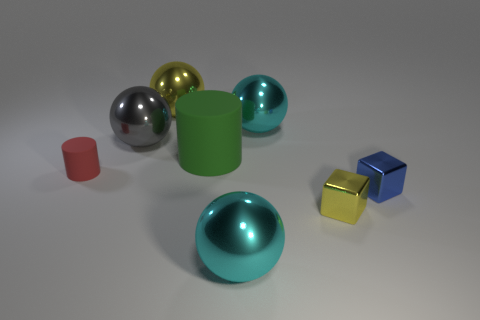Subtract all yellow shiny balls. How many balls are left? 3 Subtract all cyan spheres. How many spheres are left? 2 Subtract all cubes. How many objects are left? 6 Subtract 1 balls. How many balls are left? 3 Add 3 large purple shiny balls. How many large purple shiny balls exist? 3 Add 1 gray objects. How many objects exist? 9 Subtract 0 purple cylinders. How many objects are left? 8 Subtract all blue balls. Subtract all cyan cylinders. How many balls are left? 4 Subtract all green cubes. How many red spheres are left? 0 Subtract all small shiny cubes. Subtract all big cylinders. How many objects are left? 5 